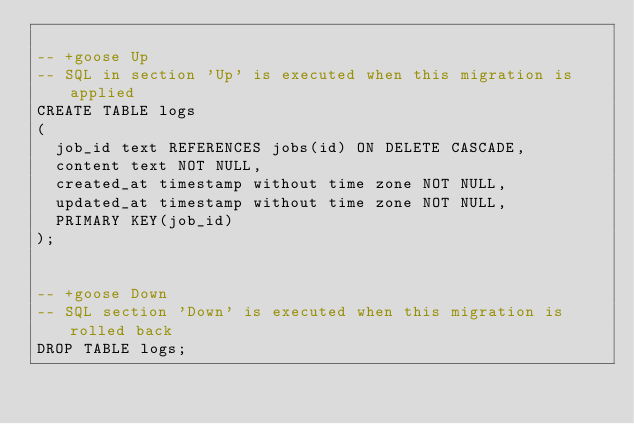Convert code to text. <code><loc_0><loc_0><loc_500><loc_500><_SQL_>
-- +goose Up
-- SQL in section 'Up' is executed when this migration is applied
CREATE TABLE logs
(
  job_id text REFERENCES jobs(id) ON DELETE CASCADE,
  content text NOT NULL,
  created_at timestamp without time zone NOT NULL,
  updated_at timestamp without time zone NOT NULL,
  PRIMARY KEY(job_id)
);


-- +goose Down
-- SQL section 'Down' is executed when this migration is rolled back
DROP TABLE logs;

</code> 